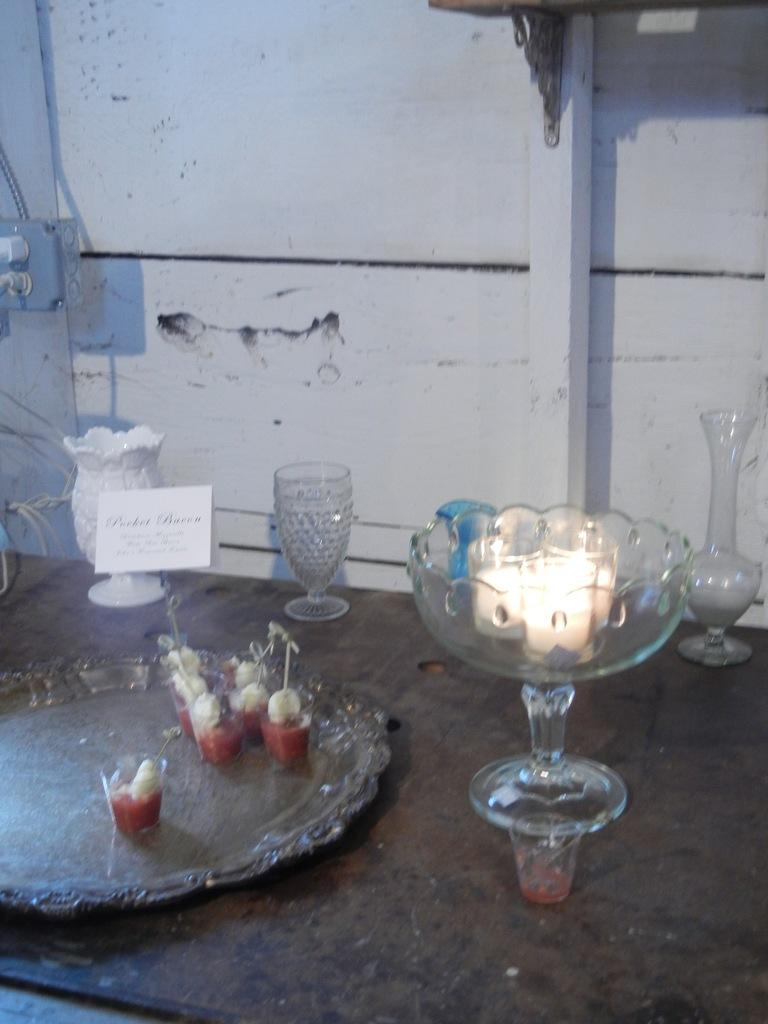What objects are on a tray in the image? There are glasses on a tray in the image. What type of food is in the glass with food? The fact does not specify the type of food in the glass. What other type of container is present in the image? There is a bowl in the image. How many additional glasses are in the image? There are additional glasses in the image, but the exact number is not specified. What is the board used for in the image? The fact does not specify the purpose of the board in the image. What can be seen in the background of the image? There is a wall in the background of the image. What type of lipstick is the creator wearing in the image? There is no mention of a creator or lipstick in the image. 